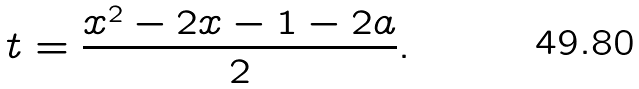<formula> <loc_0><loc_0><loc_500><loc_500>t = \frac { x ^ { 2 } - 2 x - 1 - 2 a } { 2 } .</formula> 